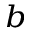Convert formula to latex. <formula><loc_0><loc_0><loc_500><loc_500>^ { b }</formula> 